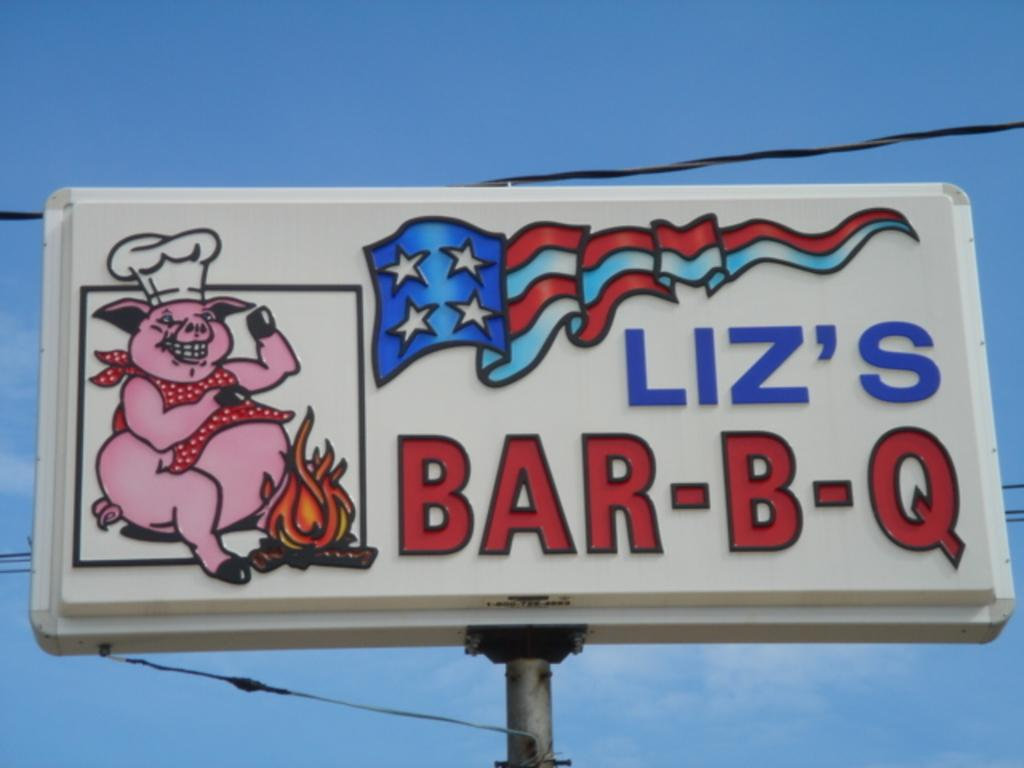<image>
Describe the image concisely. a billboard that says 'liz's bar-b-q' on it 